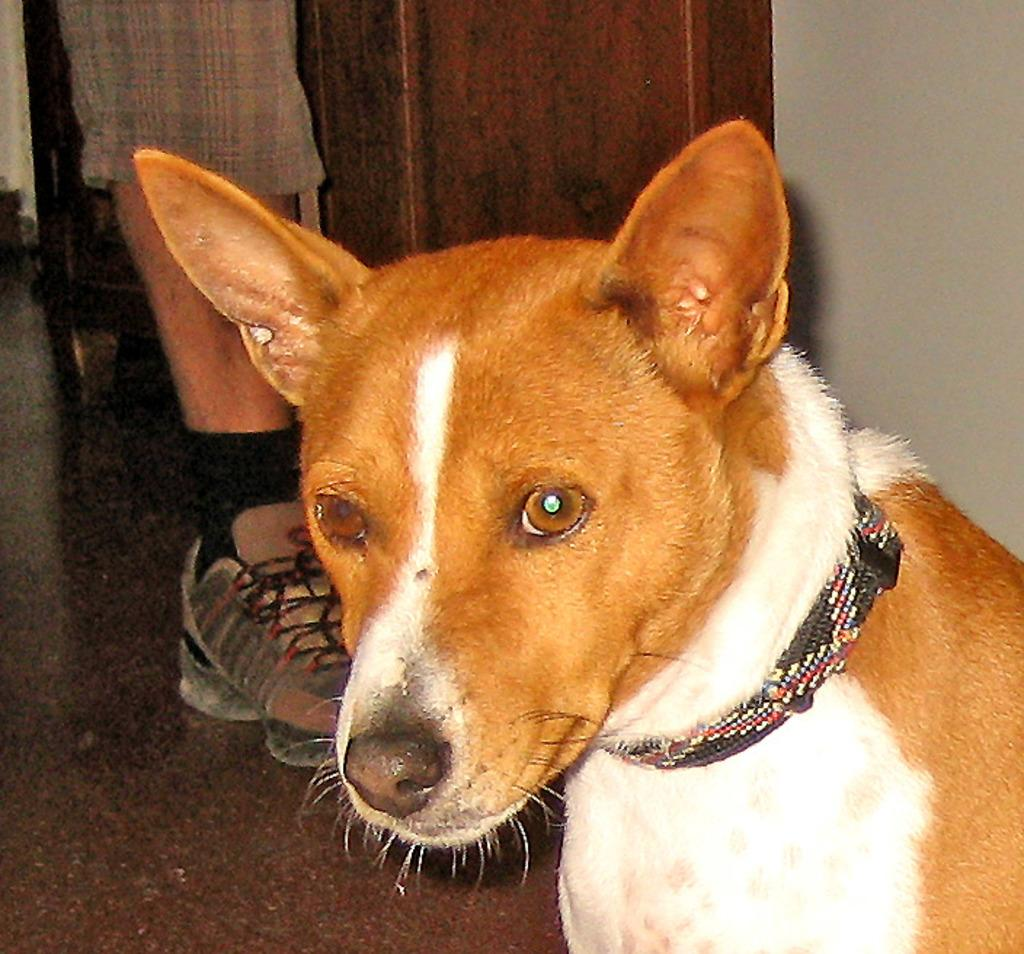What type of animal can be seen in the image? There is a dog in the image. What can be seen in the background of the image? There is a wooden object and a leg of a person with a shoe visible in the background of the image. What is visible at the bottom of the image? The floor is visible at the bottom of the image. What type of snake can be seen slithering across the dog's throat in the image? There is no snake present in the image, and the dog's throat is not visible. 